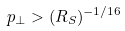<formula> <loc_0><loc_0><loc_500><loc_500>p _ { \perp } > ( R _ { S } ) ^ { - 1 / 1 6 }</formula> 